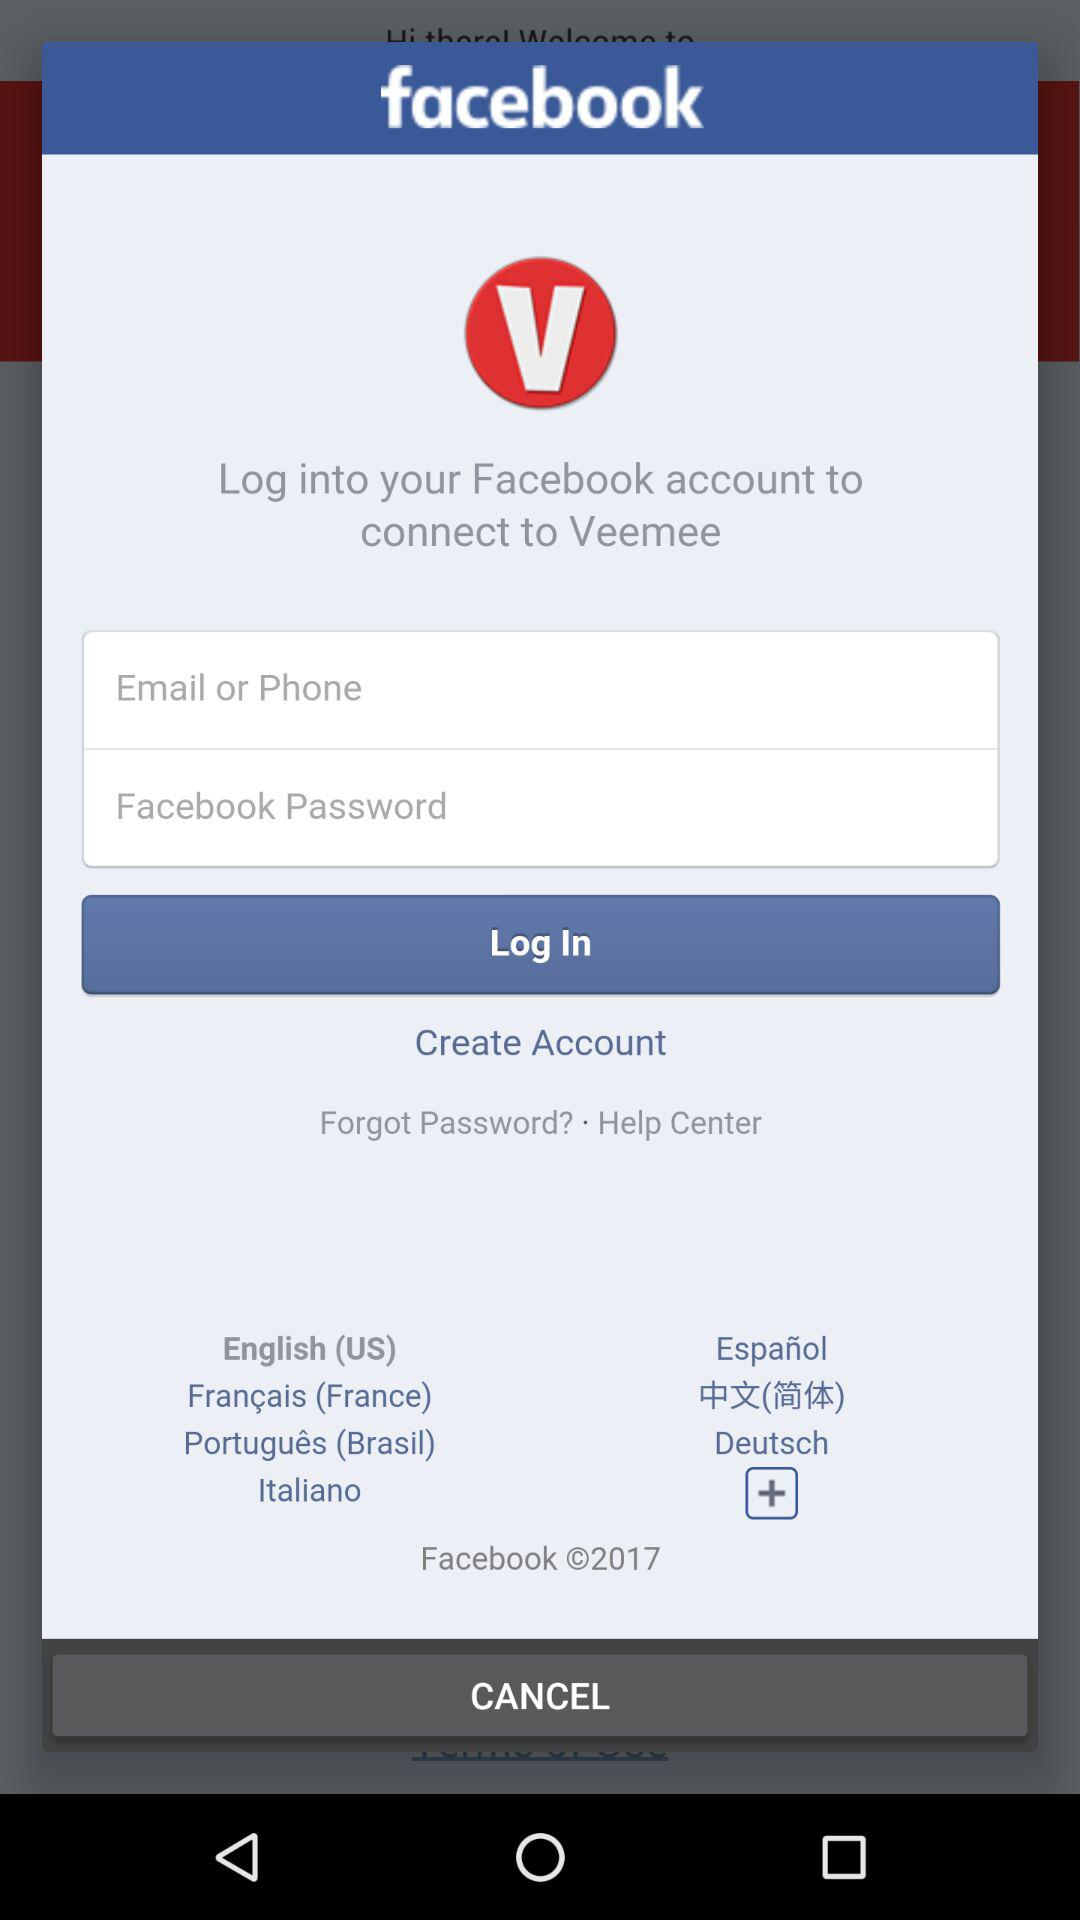How many languages are supported by Veemee?
Answer the question using a single word or phrase. 7 